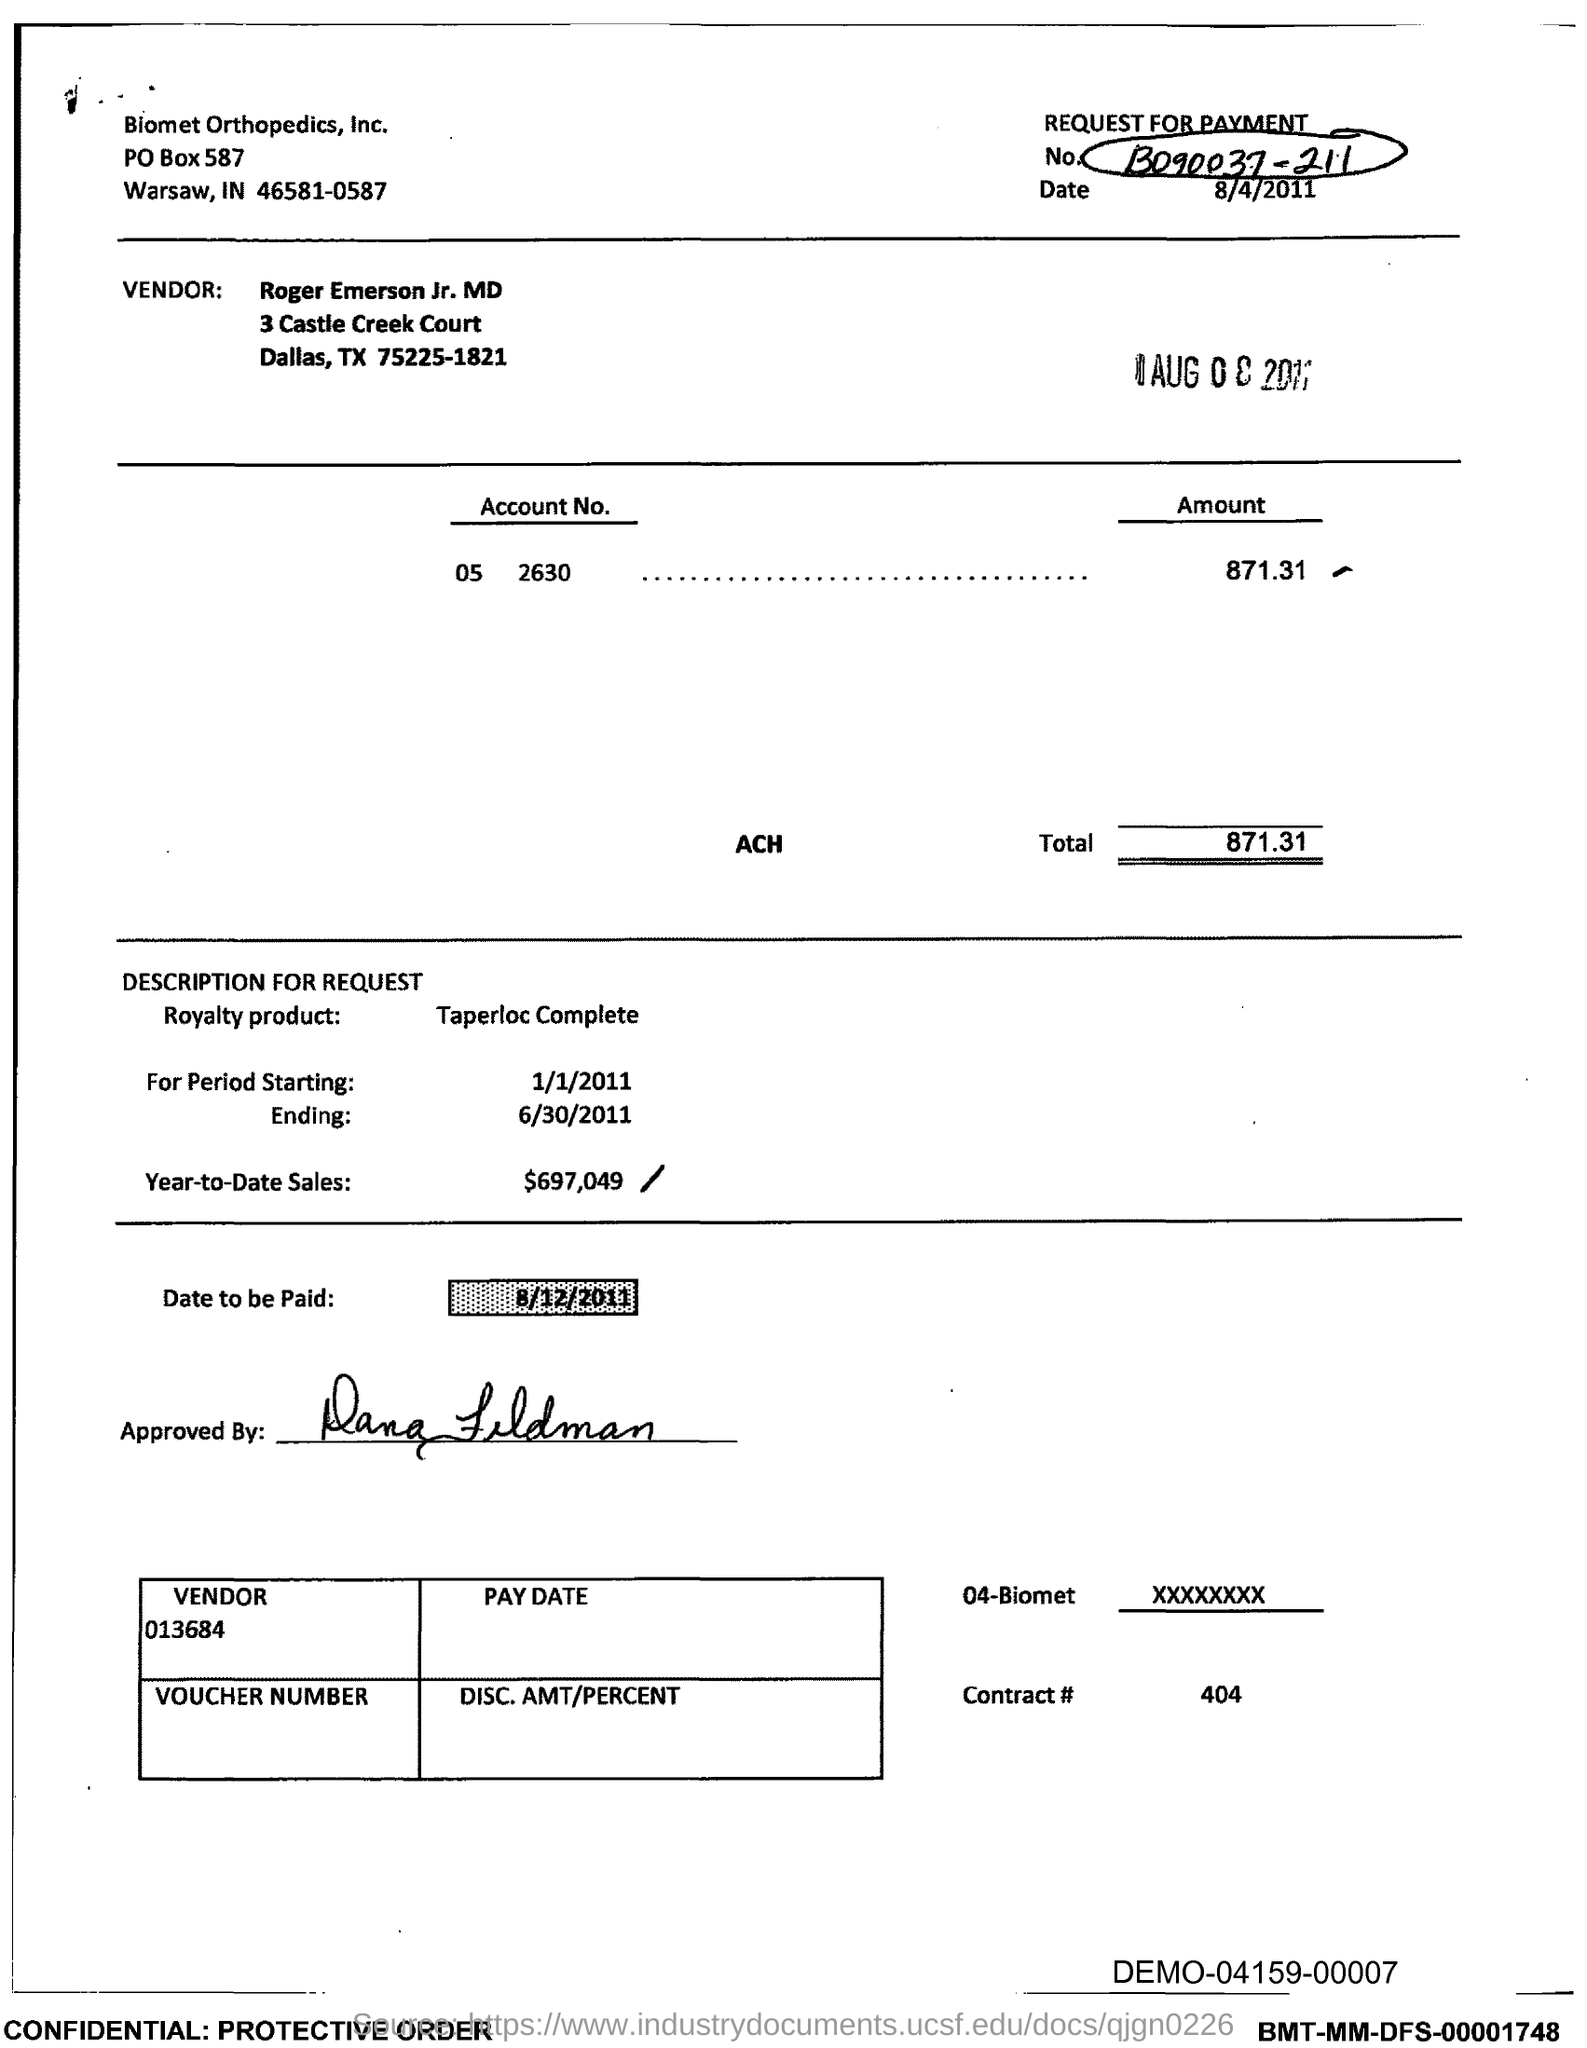Outline some significant characteristics in this image. The date to be paid is August 12, 2011. As of today, the year-to-date sales are $697,049. The contract number is 404 and no contract with this number exists. 